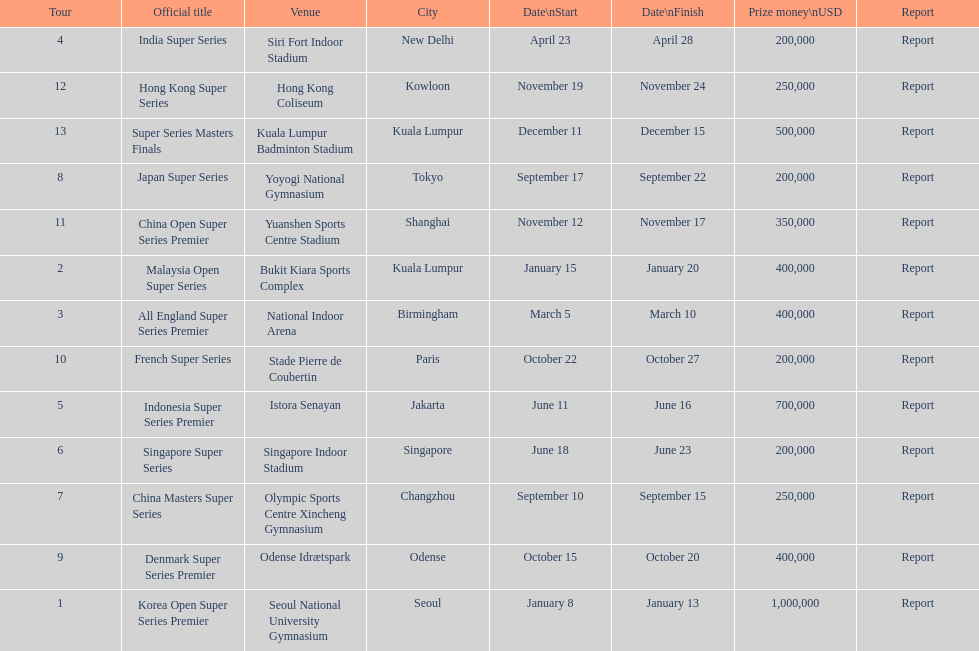How many events of the 2013 bwf super series pay over $200,000? 9. 